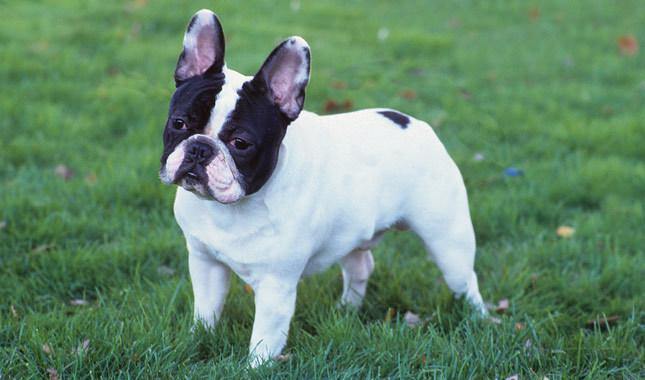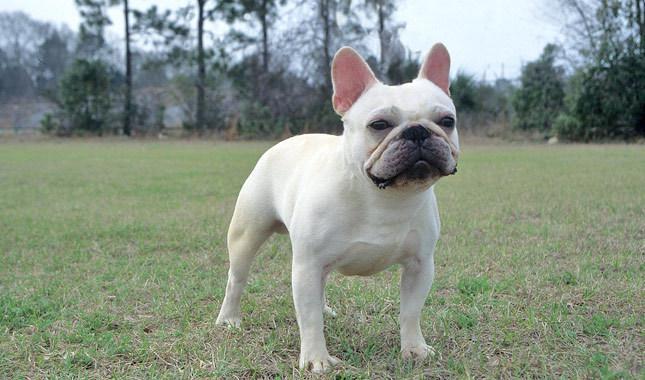The first image is the image on the left, the second image is the image on the right. Evaluate the accuracy of this statement regarding the images: "Two small dogs with ears standing up have no collar or leash.". Is it true? Answer yes or no. Yes. 